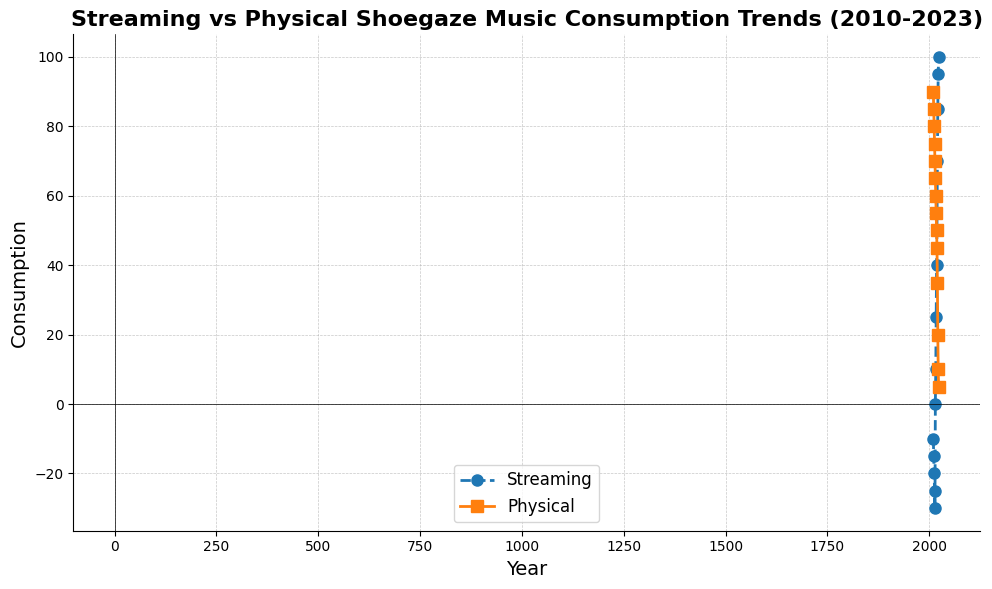What is the general trend of streaming consumption from 2010 to 2023? Streaming consumption generally increases from negative values to positive values over this period.
Answer: Increasing At which year do streaming and physical consumption appear to be closest to each other? By visually inspecting the lines, streaming and physical consumption are closest around 2015.
Answer: 2015 What year marks the transition of streaming consumption from negative to positive values? Streaming consumption moves from negative to positive between 2014 and 2015, as observed in the line chart.
Answer: 2015 How has physical consumption changed from 2010 to 2023? Physical consumption generally decreases from 90 in 2010 to 5 in 2023, indicating a downward trend.
Answer: Decreasing Which had a higher consumption in 2020, streaming or physical? Observing the values on the y-axis, streaming consumption (70) is higher than physical consumption (35) in 2020.
Answer: Streaming In which year was streaming consumption equal to zero? By identifying the year where the streaming line crosses the y-axis at zero, it is 2015.
Answer: 2015 How much did streaming consumption increase from 2016 to 2023? Streaming consumption increased from 10 in 2016 to 100 in 2023. The difference is 100 - 10 = 90.
Answer: 90 Compare the consumption values of streaming and physical in 2021. Which is greater and by how much? Streaming consumption (85) is greater than physical consumption (20), and the difference is 85 - 20 = 65.
Answer: Streaming by 65 What is the combined consumption of streaming and physical in 2013? In 2013, streaming is -25 and physical is 75. Combined consumption is -25 + 75 = 50.
Answer: 50 Identify any year where physical consumption experienced the most significant drop compared to the previous year. Between 2020 and 2021, physical consumption drops from 35 to 20, which is a 15-point drop, the largest observed.
Answer: 2021 